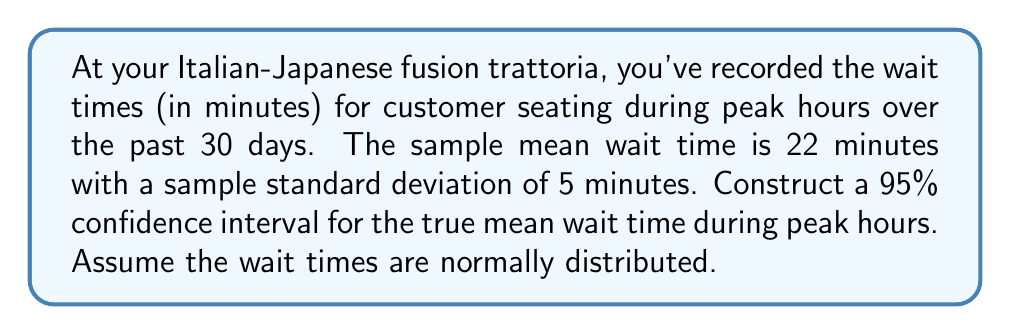Help me with this question. Let's construct the confidence interval step-by-step:

1) We're given:
   - Sample size: $n = 30$
   - Sample mean: $\bar{x} = 22$ minutes
   - Sample standard deviation: $s = 5$ minutes
   - Confidence level: 95%

2) For a 95% confidence interval, we use a $z$-score of 1.96 (assuming a large sample size).

3) The formula for the confidence interval is:

   $$\bar{x} \pm z \cdot \frac{s}{\sqrt{n}}$$

4) Substituting our values:

   $$22 \pm 1.96 \cdot \frac{5}{\sqrt{30}}$$

5) Simplify:
   $$22 \pm 1.96 \cdot \frac{5}{\sqrt{30}} = 22 \pm 1.96 \cdot 0.9129 = 22 \pm 1.7893$$

6) Calculate the interval:
   Lower bound: $22 - 1.7893 = 20.2107$
   Upper bound: $22 + 1.7893 = 23.7893$

7) Round to two decimal places:
   (20.21, 23.79)

Therefore, we can be 95% confident that the true mean wait time during peak hours is between 20.21 and 23.79 minutes.
Answer: (20.21, 23.79) minutes 